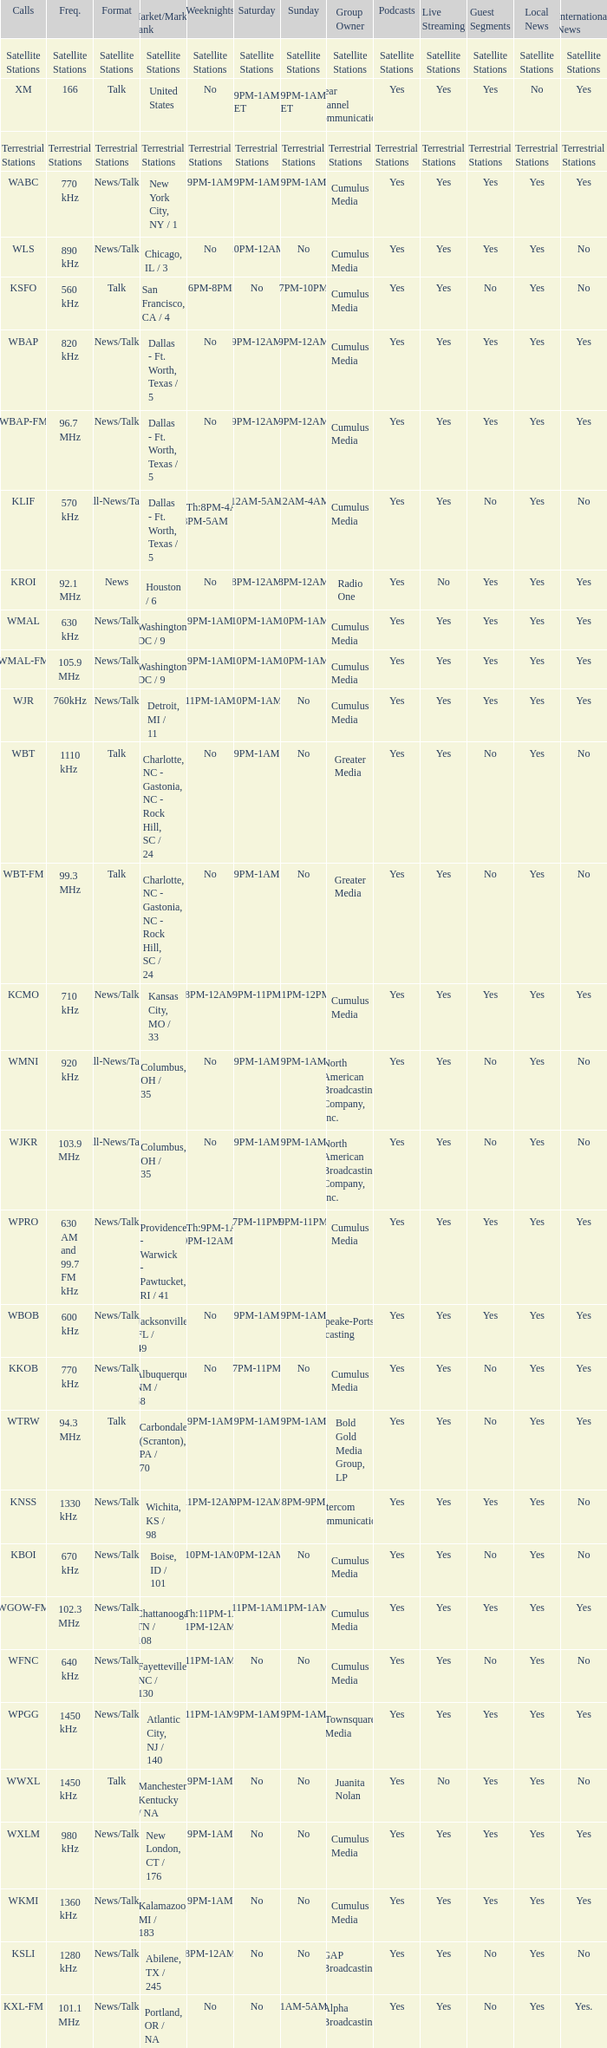What is the market for the 11pm-1am Saturday game? Chattanooga, TN / 108. 